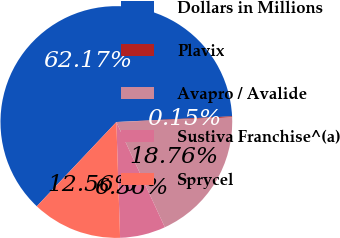Convert chart to OTSL. <chart><loc_0><loc_0><loc_500><loc_500><pie_chart><fcel>Dollars in Millions<fcel>Plavix<fcel>Avapro / Avalide<fcel>Sustiva Franchise^(a)<fcel>Sprycel<nl><fcel>62.17%<fcel>0.15%<fcel>18.76%<fcel>6.36%<fcel>12.56%<nl></chart> 